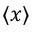Convert formula to latex. <formula><loc_0><loc_0><loc_500><loc_500>\langle x \rangle</formula> 